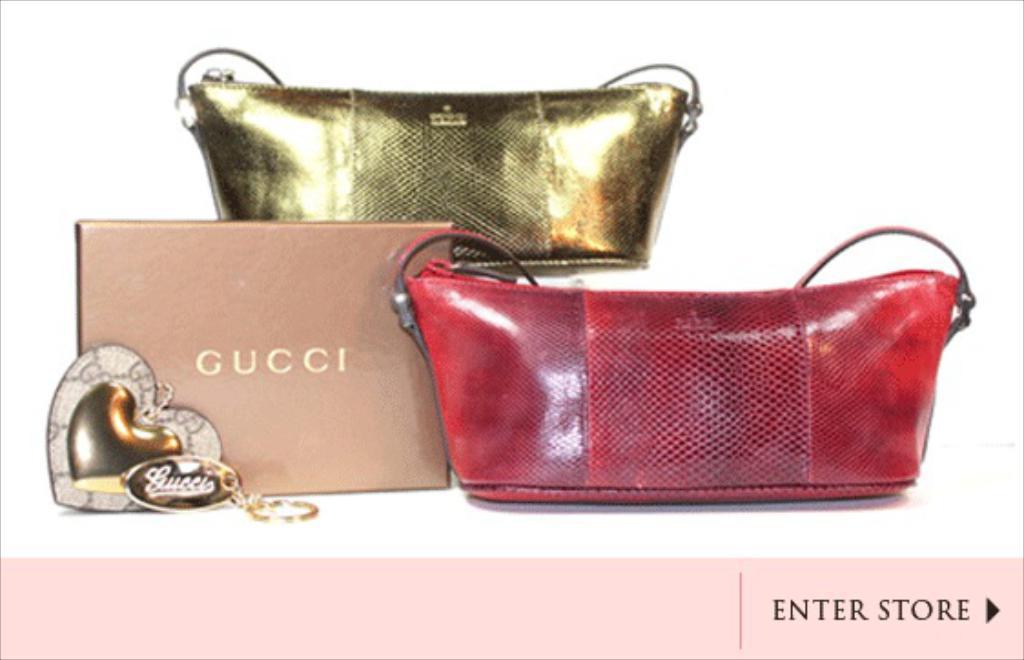Can you describe this image briefly? It is a screen shot from an online website,there are three bags of gucci company,one is red,another is cream the third one is gold, below there is an option like enter store,it is a image from an online website. 